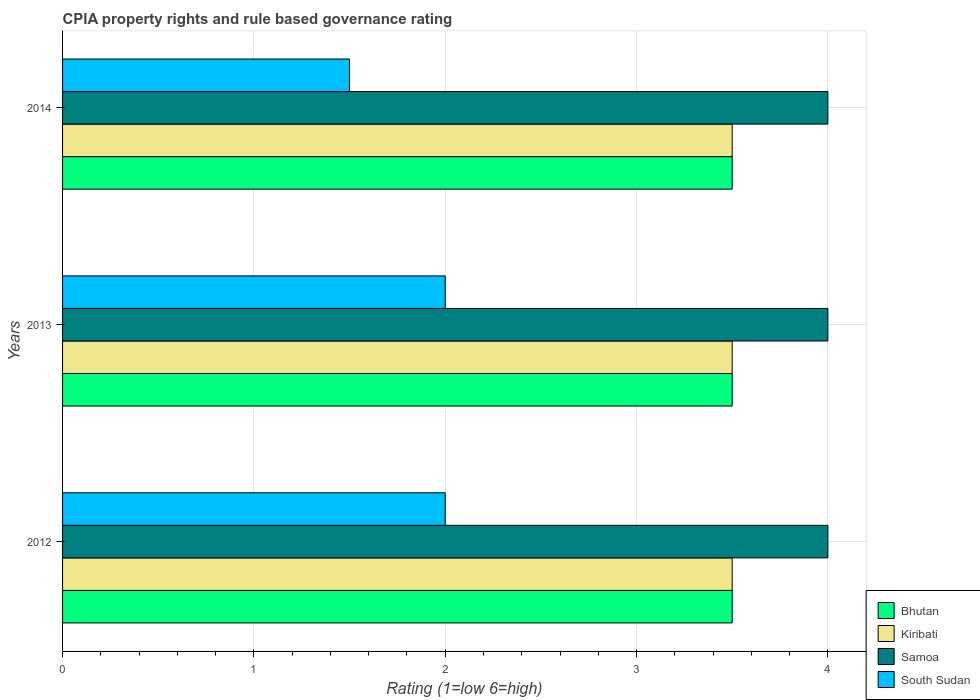How many bars are there on the 3rd tick from the top?
Your answer should be compact. 4. How many bars are there on the 3rd tick from the bottom?
Make the answer very short. 4. What is the label of the 3rd group of bars from the top?
Make the answer very short. 2012. What is the CPIA rating in Bhutan in 2013?
Make the answer very short. 3.5. Across all years, what is the minimum CPIA rating in Samoa?
Give a very brief answer. 4. In which year was the CPIA rating in Bhutan minimum?
Provide a succinct answer. 2012. What is the total CPIA rating in Kiribati in the graph?
Make the answer very short. 10.5. What is the difference between the CPIA rating in Kiribati in 2012 and that in 2013?
Offer a terse response. 0. What is the average CPIA rating in Kiribati per year?
Your response must be concise. 3.5. Is the CPIA rating in Bhutan in 2012 less than that in 2014?
Offer a terse response. No. Is the difference between the CPIA rating in Kiribati in 2012 and 2014 greater than the difference between the CPIA rating in Samoa in 2012 and 2014?
Keep it short and to the point. No. What does the 2nd bar from the top in 2013 represents?
Provide a short and direct response. Samoa. What does the 3rd bar from the bottom in 2013 represents?
Your response must be concise. Samoa. Is it the case that in every year, the sum of the CPIA rating in South Sudan and CPIA rating in Samoa is greater than the CPIA rating in Kiribati?
Your answer should be compact. Yes. How many bars are there?
Ensure brevity in your answer.  12. Are all the bars in the graph horizontal?
Keep it short and to the point. Yes. What is the difference between two consecutive major ticks on the X-axis?
Ensure brevity in your answer.  1. Are the values on the major ticks of X-axis written in scientific E-notation?
Give a very brief answer. No. Where does the legend appear in the graph?
Give a very brief answer. Bottom right. How many legend labels are there?
Offer a very short reply. 4. What is the title of the graph?
Offer a very short reply. CPIA property rights and rule based governance rating. Does "Channel Islands" appear as one of the legend labels in the graph?
Ensure brevity in your answer.  No. What is the label or title of the Y-axis?
Offer a very short reply. Years. What is the Rating (1=low 6=high) in Samoa in 2012?
Provide a succinct answer. 4. What is the Rating (1=low 6=high) in Samoa in 2013?
Offer a terse response. 4. What is the Rating (1=low 6=high) of Samoa in 2014?
Provide a succinct answer. 4. What is the Rating (1=low 6=high) in South Sudan in 2014?
Your response must be concise. 1.5. Across all years, what is the maximum Rating (1=low 6=high) of Bhutan?
Keep it short and to the point. 3.5. Across all years, what is the maximum Rating (1=low 6=high) in Kiribati?
Your response must be concise. 3.5. Across all years, what is the maximum Rating (1=low 6=high) in Samoa?
Make the answer very short. 4. Across all years, what is the minimum Rating (1=low 6=high) in Kiribati?
Your answer should be very brief. 3.5. Across all years, what is the minimum Rating (1=low 6=high) of South Sudan?
Make the answer very short. 1.5. What is the total Rating (1=low 6=high) in South Sudan in the graph?
Your answer should be compact. 5.5. What is the difference between the Rating (1=low 6=high) in South Sudan in 2012 and that in 2014?
Offer a very short reply. 0.5. What is the difference between the Rating (1=low 6=high) in Bhutan in 2013 and that in 2014?
Provide a short and direct response. 0. What is the difference between the Rating (1=low 6=high) of Samoa in 2013 and that in 2014?
Keep it short and to the point. 0. What is the difference between the Rating (1=low 6=high) in Bhutan in 2012 and the Rating (1=low 6=high) in South Sudan in 2013?
Make the answer very short. 1.5. What is the difference between the Rating (1=low 6=high) of Kiribati in 2012 and the Rating (1=low 6=high) of Samoa in 2013?
Provide a short and direct response. -0.5. What is the difference between the Rating (1=low 6=high) of Samoa in 2012 and the Rating (1=low 6=high) of South Sudan in 2013?
Ensure brevity in your answer.  2. What is the difference between the Rating (1=low 6=high) of Bhutan in 2012 and the Rating (1=low 6=high) of Kiribati in 2014?
Offer a terse response. 0. What is the difference between the Rating (1=low 6=high) of Bhutan in 2012 and the Rating (1=low 6=high) of South Sudan in 2014?
Provide a succinct answer. 2. What is the difference between the Rating (1=low 6=high) in Kiribati in 2012 and the Rating (1=low 6=high) in Samoa in 2014?
Give a very brief answer. -0.5. What is the difference between the Rating (1=low 6=high) in Kiribati in 2012 and the Rating (1=low 6=high) in South Sudan in 2014?
Provide a short and direct response. 2. What is the difference between the Rating (1=low 6=high) in Samoa in 2012 and the Rating (1=low 6=high) in South Sudan in 2014?
Make the answer very short. 2.5. What is the difference between the Rating (1=low 6=high) in Kiribati in 2013 and the Rating (1=low 6=high) in Samoa in 2014?
Your answer should be very brief. -0.5. What is the difference between the Rating (1=low 6=high) in Samoa in 2013 and the Rating (1=low 6=high) in South Sudan in 2014?
Provide a succinct answer. 2.5. What is the average Rating (1=low 6=high) of Bhutan per year?
Keep it short and to the point. 3.5. What is the average Rating (1=low 6=high) of Kiribati per year?
Give a very brief answer. 3.5. What is the average Rating (1=low 6=high) in Samoa per year?
Your answer should be compact. 4. What is the average Rating (1=low 6=high) of South Sudan per year?
Your response must be concise. 1.83. In the year 2012, what is the difference between the Rating (1=low 6=high) of Bhutan and Rating (1=low 6=high) of Kiribati?
Your answer should be compact. 0. In the year 2012, what is the difference between the Rating (1=low 6=high) of Bhutan and Rating (1=low 6=high) of Samoa?
Your answer should be compact. -0.5. In the year 2013, what is the difference between the Rating (1=low 6=high) in Bhutan and Rating (1=low 6=high) in Samoa?
Offer a very short reply. -0.5. In the year 2013, what is the difference between the Rating (1=low 6=high) in Bhutan and Rating (1=low 6=high) in South Sudan?
Your response must be concise. 1.5. In the year 2013, what is the difference between the Rating (1=low 6=high) in Kiribati and Rating (1=low 6=high) in South Sudan?
Offer a terse response. 1.5. In the year 2013, what is the difference between the Rating (1=low 6=high) in Samoa and Rating (1=low 6=high) in South Sudan?
Provide a succinct answer. 2. In the year 2014, what is the difference between the Rating (1=low 6=high) in Bhutan and Rating (1=low 6=high) in South Sudan?
Offer a very short reply. 2. In the year 2014, what is the difference between the Rating (1=low 6=high) of Kiribati and Rating (1=low 6=high) of Samoa?
Provide a succinct answer. -0.5. In the year 2014, what is the difference between the Rating (1=low 6=high) of Samoa and Rating (1=low 6=high) of South Sudan?
Provide a short and direct response. 2.5. What is the ratio of the Rating (1=low 6=high) of Bhutan in 2012 to that in 2013?
Keep it short and to the point. 1. What is the ratio of the Rating (1=low 6=high) of Kiribati in 2012 to that in 2013?
Offer a very short reply. 1. What is the ratio of the Rating (1=low 6=high) of Bhutan in 2012 to that in 2014?
Give a very brief answer. 1. What is the ratio of the Rating (1=low 6=high) in Kiribati in 2012 to that in 2014?
Your response must be concise. 1. What is the ratio of the Rating (1=low 6=high) of Samoa in 2012 to that in 2014?
Your answer should be very brief. 1. What is the ratio of the Rating (1=low 6=high) of Bhutan in 2013 to that in 2014?
Offer a very short reply. 1. What is the ratio of the Rating (1=low 6=high) in Kiribati in 2013 to that in 2014?
Provide a succinct answer. 1. What is the difference between the highest and the second highest Rating (1=low 6=high) in Kiribati?
Your response must be concise. 0. What is the difference between the highest and the second highest Rating (1=low 6=high) of Samoa?
Provide a succinct answer. 0. What is the difference between the highest and the second highest Rating (1=low 6=high) of South Sudan?
Offer a very short reply. 0. What is the difference between the highest and the lowest Rating (1=low 6=high) of South Sudan?
Offer a very short reply. 0.5. 